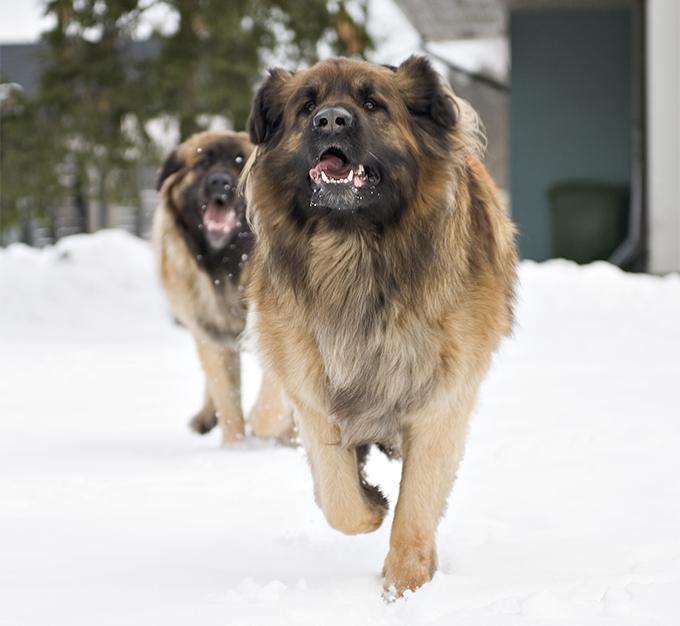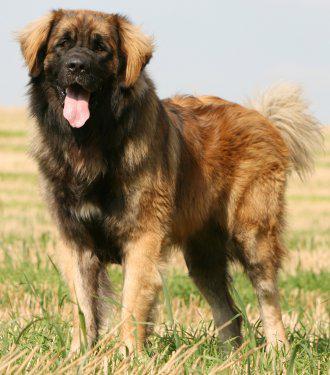The first image is the image on the left, the second image is the image on the right. For the images displayed, is the sentence "A person is posed with one big dog that is standing with its body turned rightward." factually correct? Answer yes or no. No. The first image is the image on the left, the second image is the image on the right. Analyze the images presented: Is the assertion "All images show camera-facing dogs, and all dogs look similar in coloring and breed." valid? Answer yes or no. Yes. The first image is the image on the left, the second image is the image on the right. Assess this claim about the two images: "There is only one dog in each image and it has its mouth open.". Correct or not? Answer yes or no. No. The first image is the image on the left, the second image is the image on the right. Assess this claim about the two images: "An image shows a toddler girl next to a large dog.". Correct or not? Answer yes or no. No. The first image is the image on the left, the second image is the image on the right. Considering the images on both sides, is "A large dog is standing outdoors next to a human." valid? Answer yes or no. No. 